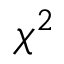Convert formula to latex. <formula><loc_0><loc_0><loc_500><loc_500>\chi ^ { 2 }</formula> 